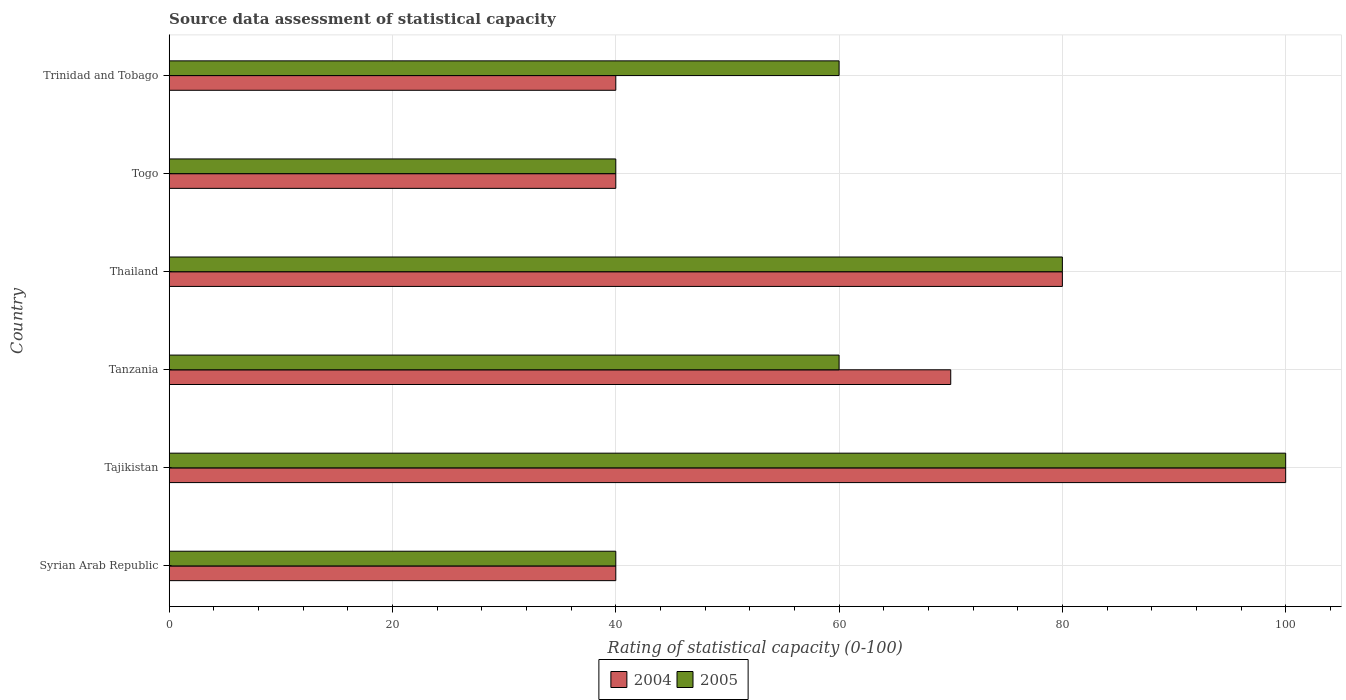How many different coloured bars are there?
Provide a succinct answer. 2. How many groups of bars are there?
Give a very brief answer. 6. How many bars are there on the 1st tick from the bottom?
Make the answer very short. 2. What is the label of the 3rd group of bars from the top?
Your response must be concise. Thailand. In how many cases, is the number of bars for a given country not equal to the number of legend labels?
Your response must be concise. 0. Across all countries, what is the maximum rating of statistical capacity in 2005?
Make the answer very short. 100. Across all countries, what is the minimum rating of statistical capacity in 2004?
Ensure brevity in your answer.  40. In which country was the rating of statistical capacity in 2004 maximum?
Your answer should be compact. Tajikistan. In which country was the rating of statistical capacity in 2004 minimum?
Offer a terse response. Syrian Arab Republic. What is the total rating of statistical capacity in 2004 in the graph?
Your answer should be very brief. 370. What is the difference between the rating of statistical capacity in 2005 in Syrian Arab Republic and that in Tanzania?
Provide a succinct answer. -20. What is the difference between the rating of statistical capacity in 2005 in Thailand and the rating of statistical capacity in 2004 in Togo?
Keep it short and to the point. 40. What is the average rating of statistical capacity in 2005 per country?
Make the answer very short. 63.33. What is the ratio of the rating of statistical capacity in 2005 in Tanzania to that in Thailand?
Your answer should be compact. 0.75. In how many countries, is the rating of statistical capacity in 2005 greater than the average rating of statistical capacity in 2005 taken over all countries?
Provide a short and direct response. 2. Is the sum of the rating of statistical capacity in 2005 in Tajikistan and Tanzania greater than the maximum rating of statistical capacity in 2004 across all countries?
Your answer should be very brief. Yes. Are all the bars in the graph horizontal?
Offer a very short reply. Yes. What is the difference between two consecutive major ticks on the X-axis?
Your response must be concise. 20. Are the values on the major ticks of X-axis written in scientific E-notation?
Provide a succinct answer. No. Where does the legend appear in the graph?
Your answer should be compact. Bottom center. How are the legend labels stacked?
Offer a terse response. Horizontal. What is the title of the graph?
Keep it short and to the point. Source data assessment of statistical capacity. What is the label or title of the X-axis?
Make the answer very short. Rating of statistical capacity (0-100). What is the label or title of the Y-axis?
Ensure brevity in your answer.  Country. What is the Rating of statistical capacity (0-100) in 2004 in Syrian Arab Republic?
Give a very brief answer. 40. What is the Rating of statistical capacity (0-100) in 2005 in Syrian Arab Republic?
Your response must be concise. 40. What is the Rating of statistical capacity (0-100) in 2005 in Tanzania?
Your response must be concise. 60. What is the Rating of statistical capacity (0-100) of 2004 in Thailand?
Make the answer very short. 80. Across all countries, what is the maximum Rating of statistical capacity (0-100) of 2004?
Make the answer very short. 100. Across all countries, what is the maximum Rating of statistical capacity (0-100) of 2005?
Keep it short and to the point. 100. Across all countries, what is the minimum Rating of statistical capacity (0-100) of 2004?
Provide a short and direct response. 40. What is the total Rating of statistical capacity (0-100) of 2004 in the graph?
Your answer should be compact. 370. What is the total Rating of statistical capacity (0-100) of 2005 in the graph?
Make the answer very short. 380. What is the difference between the Rating of statistical capacity (0-100) of 2004 in Syrian Arab Republic and that in Tajikistan?
Make the answer very short. -60. What is the difference between the Rating of statistical capacity (0-100) in 2005 in Syrian Arab Republic and that in Tajikistan?
Keep it short and to the point. -60. What is the difference between the Rating of statistical capacity (0-100) of 2004 in Syrian Arab Republic and that in Tanzania?
Keep it short and to the point. -30. What is the difference between the Rating of statistical capacity (0-100) in 2005 in Syrian Arab Republic and that in Tanzania?
Provide a short and direct response. -20. What is the difference between the Rating of statistical capacity (0-100) of 2004 in Syrian Arab Republic and that in Togo?
Offer a terse response. 0. What is the difference between the Rating of statistical capacity (0-100) in 2004 in Syrian Arab Republic and that in Trinidad and Tobago?
Give a very brief answer. 0. What is the difference between the Rating of statistical capacity (0-100) in 2005 in Tajikistan and that in Tanzania?
Offer a very short reply. 40. What is the difference between the Rating of statistical capacity (0-100) of 2004 in Tajikistan and that in Togo?
Keep it short and to the point. 60. What is the difference between the Rating of statistical capacity (0-100) in 2005 in Tajikistan and that in Togo?
Offer a very short reply. 60. What is the difference between the Rating of statistical capacity (0-100) of 2004 in Tajikistan and that in Trinidad and Tobago?
Give a very brief answer. 60. What is the difference between the Rating of statistical capacity (0-100) of 2004 in Tanzania and that in Togo?
Provide a succinct answer. 30. What is the difference between the Rating of statistical capacity (0-100) in 2005 in Tanzania and that in Togo?
Offer a very short reply. 20. What is the difference between the Rating of statistical capacity (0-100) in 2004 in Tanzania and that in Trinidad and Tobago?
Offer a terse response. 30. What is the difference between the Rating of statistical capacity (0-100) of 2004 in Togo and that in Trinidad and Tobago?
Your response must be concise. 0. What is the difference between the Rating of statistical capacity (0-100) of 2005 in Togo and that in Trinidad and Tobago?
Make the answer very short. -20. What is the difference between the Rating of statistical capacity (0-100) in 2004 in Syrian Arab Republic and the Rating of statistical capacity (0-100) in 2005 in Tajikistan?
Give a very brief answer. -60. What is the difference between the Rating of statistical capacity (0-100) of 2004 in Syrian Arab Republic and the Rating of statistical capacity (0-100) of 2005 in Togo?
Offer a terse response. 0. What is the difference between the Rating of statistical capacity (0-100) in 2004 in Syrian Arab Republic and the Rating of statistical capacity (0-100) in 2005 in Trinidad and Tobago?
Your answer should be compact. -20. What is the difference between the Rating of statistical capacity (0-100) of 2004 in Tajikistan and the Rating of statistical capacity (0-100) of 2005 in Tanzania?
Ensure brevity in your answer.  40. What is the difference between the Rating of statistical capacity (0-100) in 2004 in Tajikistan and the Rating of statistical capacity (0-100) in 2005 in Thailand?
Your response must be concise. 20. What is the difference between the Rating of statistical capacity (0-100) in 2004 in Tanzania and the Rating of statistical capacity (0-100) in 2005 in Thailand?
Give a very brief answer. -10. What is the difference between the Rating of statistical capacity (0-100) of 2004 in Thailand and the Rating of statistical capacity (0-100) of 2005 in Togo?
Your response must be concise. 40. What is the difference between the Rating of statistical capacity (0-100) in 2004 in Togo and the Rating of statistical capacity (0-100) in 2005 in Trinidad and Tobago?
Provide a short and direct response. -20. What is the average Rating of statistical capacity (0-100) of 2004 per country?
Keep it short and to the point. 61.67. What is the average Rating of statistical capacity (0-100) of 2005 per country?
Your response must be concise. 63.33. What is the difference between the Rating of statistical capacity (0-100) of 2004 and Rating of statistical capacity (0-100) of 2005 in Tajikistan?
Your response must be concise. 0. What is the ratio of the Rating of statistical capacity (0-100) of 2004 in Syrian Arab Republic to that in Thailand?
Offer a very short reply. 0.5. What is the ratio of the Rating of statistical capacity (0-100) of 2004 in Syrian Arab Republic to that in Trinidad and Tobago?
Provide a succinct answer. 1. What is the ratio of the Rating of statistical capacity (0-100) in 2005 in Syrian Arab Republic to that in Trinidad and Tobago?
Offer a very short reply. 0.67. What is the ratio of the Rating of statistical capacity (0-100) of 2004 in Tajikistan to that in Tanzania?
Give a very brief answer. 1.43. What is the ratio of the Rating of statistical capacity (0-100) of 2005 in Tajikistan to that in Tanzania?
Offer a very short reply. 1.67. What is the ratio of the Rating of statistical capacity (0-100) in 2004 in Tajikistan to that in Togo?
Provide a succinct answer. 2.5. What is the ratio of the Rating of statistical capacity (0-100) in 2005 in Tajikistan to that in Trinidad and Tobago?
Keep it short and to the point. 1.67. What is the ratio of the Rating of statistical capacity (0-100) in 2004 in Tanzania to that in Togo?
Keep it short and to the point. 1.75. What is the ratio of the Rating of statistical capacity (0-100) of 2005 in Tanzania to that in Togo?
Ensure brevity in your answer.  1.5. What is the ratio of the Rating of statistical capacity (0-100) of 2004 in Tanzania to that in Trinidad and Tobago?
Your answer should be compact. 1.75. What is the ratio of the Rating of statistical capacity (0-100) in 2004 in Thailand to that in Togo?
Make the answer very short. 2. What is the ratio of the Rating of statistical capacity (0-100) in 2005 in Thailand to that in Trinidad and Tobago?
Offer a very short reply. 1.33. What is the ratio of the Rating of statistical capacity (0-100) of 2004 in Togo to that in Trinidad and Tobago?
Offer a terse response. 1. What is the ratio of the Rating of statistical capacity (0-100) of 2005 in Togo to that in Trinidad and Tobago?
Keep it short and to the point. 0.67. What is the difference between the highest and the second highest Rating of statistical capacity (0-100) in 2004?
Keep it short and to the point. 20. What is the difference between the highest and the lowest Rating of statistical capacity (0-100) in 2005?
Your answer should be very brief. 60. 